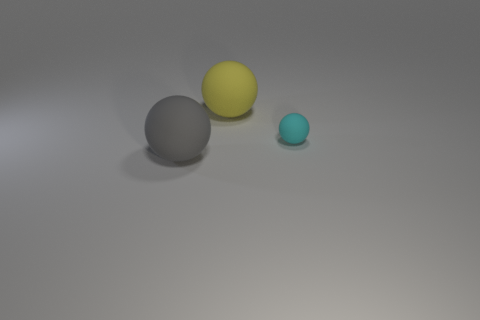Add 3 gray rubber balls. How many objects exist? 6 Subtract all large matte spheres. How many spheres are left? 1 Subtract all red balls. Subtract all purple cubes. How many balls are left? 3 Subtract 0 brown cylinders. How many objects are left? 3 Subtract all purple metallic cylinders. Subtract all yellow matte spheres. How many objects are left? 2 Add 3 big spheres. How many big spheres are left? 5 Add 3 large yellow matte spheres. How many large yellow matte spheres exist? 4 